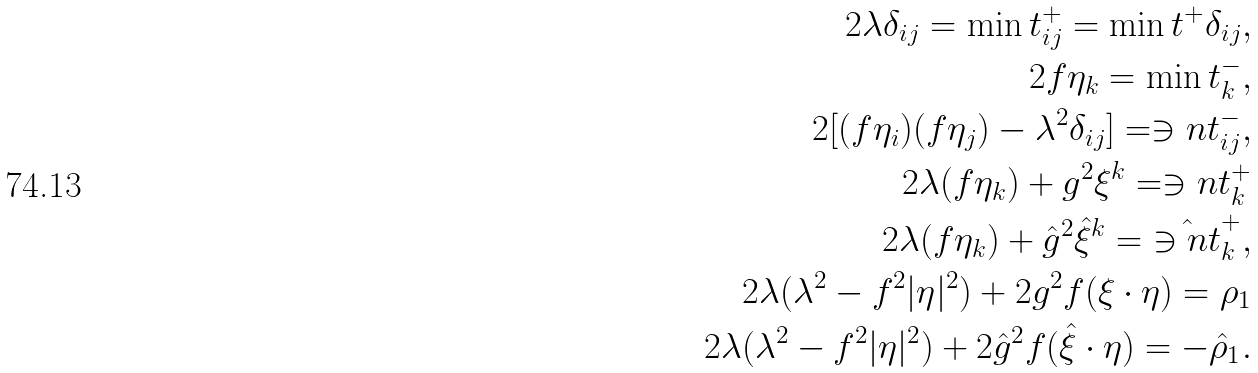<formula> <loc_0><loc_0><loc_500><loc_500>2 \lambda \delta _ { i j } = \min t ^ { + } _ { i j } = \min t ^ { + } \delta _ { i j } , \\ 2 f \eta _ { k } = \min t ^ { - } _ { k } , \\ 2 [ ( f \eta _ { i } ) ( f \eta _ { j } ) - \lambda ^ { 2 } \delta _ { i j } ] = \ni n t ^ { - } _ { i j } , \\ 2 \lambda ( f \eta _ { k } ) + g ^ { 2 } \xi ^ { k } = \ni n t ^ { + } _ { k } \\ 2 \lambda ( f \eta _ { k } ) + \hat { g } ^ { 2 } \hat { \xi } ^ { k } = \hat { \ni n t } ^ { + } _ { k } , \\ 2 \lambda ( \lambda ^ { 2 } - f ^ { 2 } | \eta | ^ { 2 } ) + 2 g ^ { 2 } f ( \xi \cdot \eta ) = \rho _ { 1 } \\ 2 \lambda ( \lambda ^ { 2 } - f ^ { 2 } | \eta | ^ { 2 } ) + 2 \hat { g } ^ { 2 } f ( \hat { \xi } \cdot \eta ) = - \hat { \rho } _ { 1 } .</formula> 